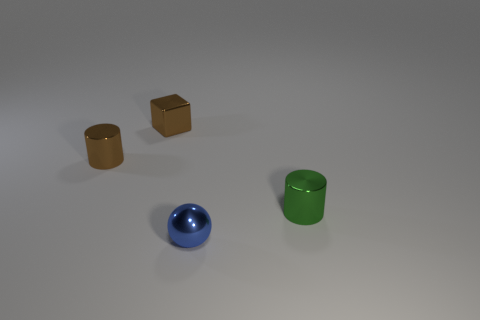What is the object that is behind the thing on the left side of the brown block made of? The object that appears behind the spherical object on the left side of the image is a cylindrical container, and it appears to be made of a material with reflective properties similar to that of polished metal, likely stainless steel. 